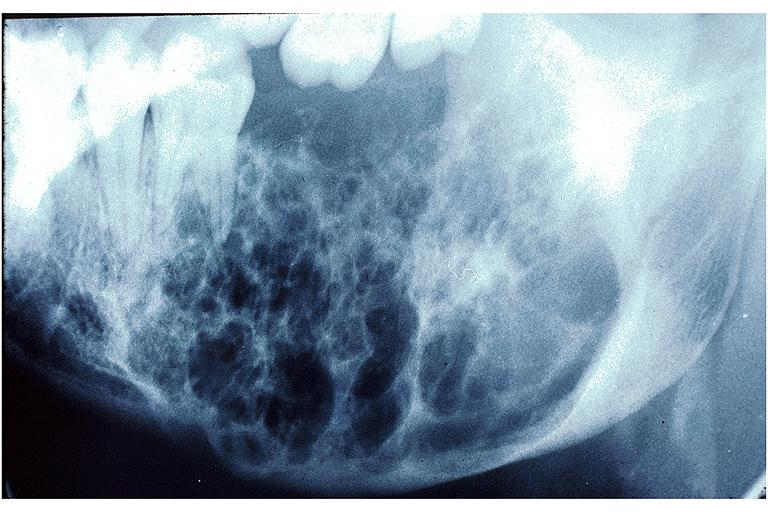s leukoplakia vocal cord present?
Answer the question using a single word or phrase. No 